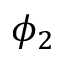Convert formula to latex. <formula><loc_0><loc_0><loc_500><loc_500>\phi _ { 2 }</formula> 